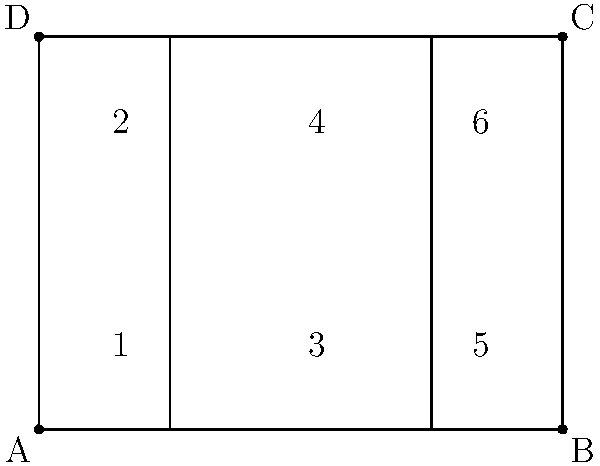In the diagram above, two parallel lines are intersected by two transversals. If angle 1 measures 45°, what is the measure of angle 6? Provide your reasoning, considering how this geometric principle might be applied to fact-checking in journalism. Let's approach this step-by-step, relating it to the critical thinking skills essential in journalism:

1) First, we need to identify the key geometric principle at play here. When parallel lines are cut by a transversal, corresponding angles are congruent. This is similar to how in journalism, we look for consistent patterns in information.

2) In this diagram, angles 1 and 5 are corresponding angles. So are angles 2 and 6. This means:
   $$\angle 1 = \angle 5$$ and $$\angle 2 = \angle 6$$

3) We're given that $\angle 1 = 45°$. Therefore, $\angle 5$ must also be 45°.

4) Another important principle is that when a straight line intersects two other lines, the angles on a straight line add up to 180°. In journalistic terms, this is like ensuring that all parts of a story add up to a complete picture. So:
   $$\angle 5 + \angle 6 = 180°$$

5) We can now set up an equation:
   $$45° + \angle 6 = 180°$$

6) Solving for $\angle 6$:
   $$\angle 6 = 180° - 45° = 135°$$

This process of logical deduction is similar to how a journalist might piece together information from various sources to arrive at a conclusion. It's crucial to base conclusions on solid evidence and logical reasoning, just as we've done here with geometric principles.
Answer: 135° 